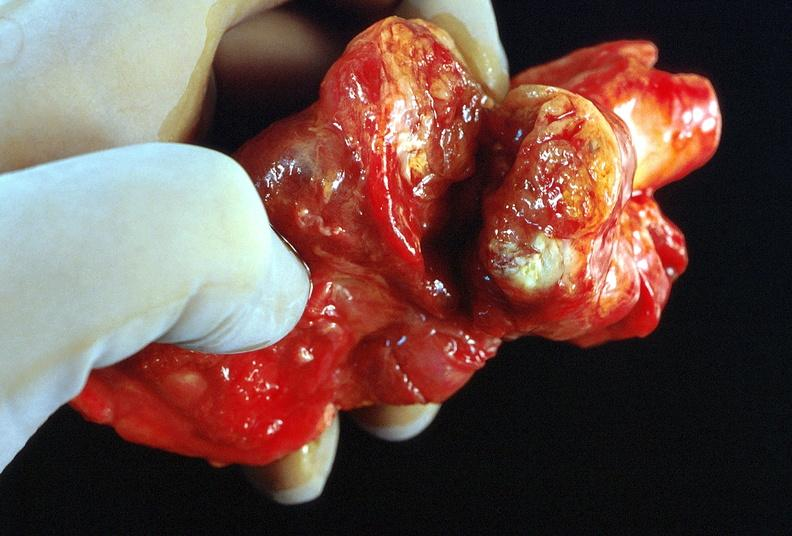s endocrine present?
Answer the question using a single word or phrase. Yes 